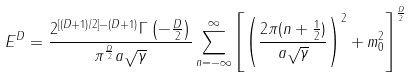<formula> <loc_0><loc_0><loc_500><loc_500>E ^ { D } = \frac { 2 ^ { [ ( D + 1 ) / 2 ] - ( D + 1 ) } \Gamma \left ( - \frac { D } { 2 } \right ) } { \pi ^ { \frac { D } { 2 } } a \sqrt { \gamma } } \sum _ { n = - \infty } ^ { \infty } \left [ \left ( \frac { 2 \pi ( n + \frac { 1 } { 2 } ) } { a \sqrt { \gamma } } \right ) ^ { 2 } + m _ { 0 } ^ { 2 } \right ] ^ { \frac { D } { 2 } }</formula> 